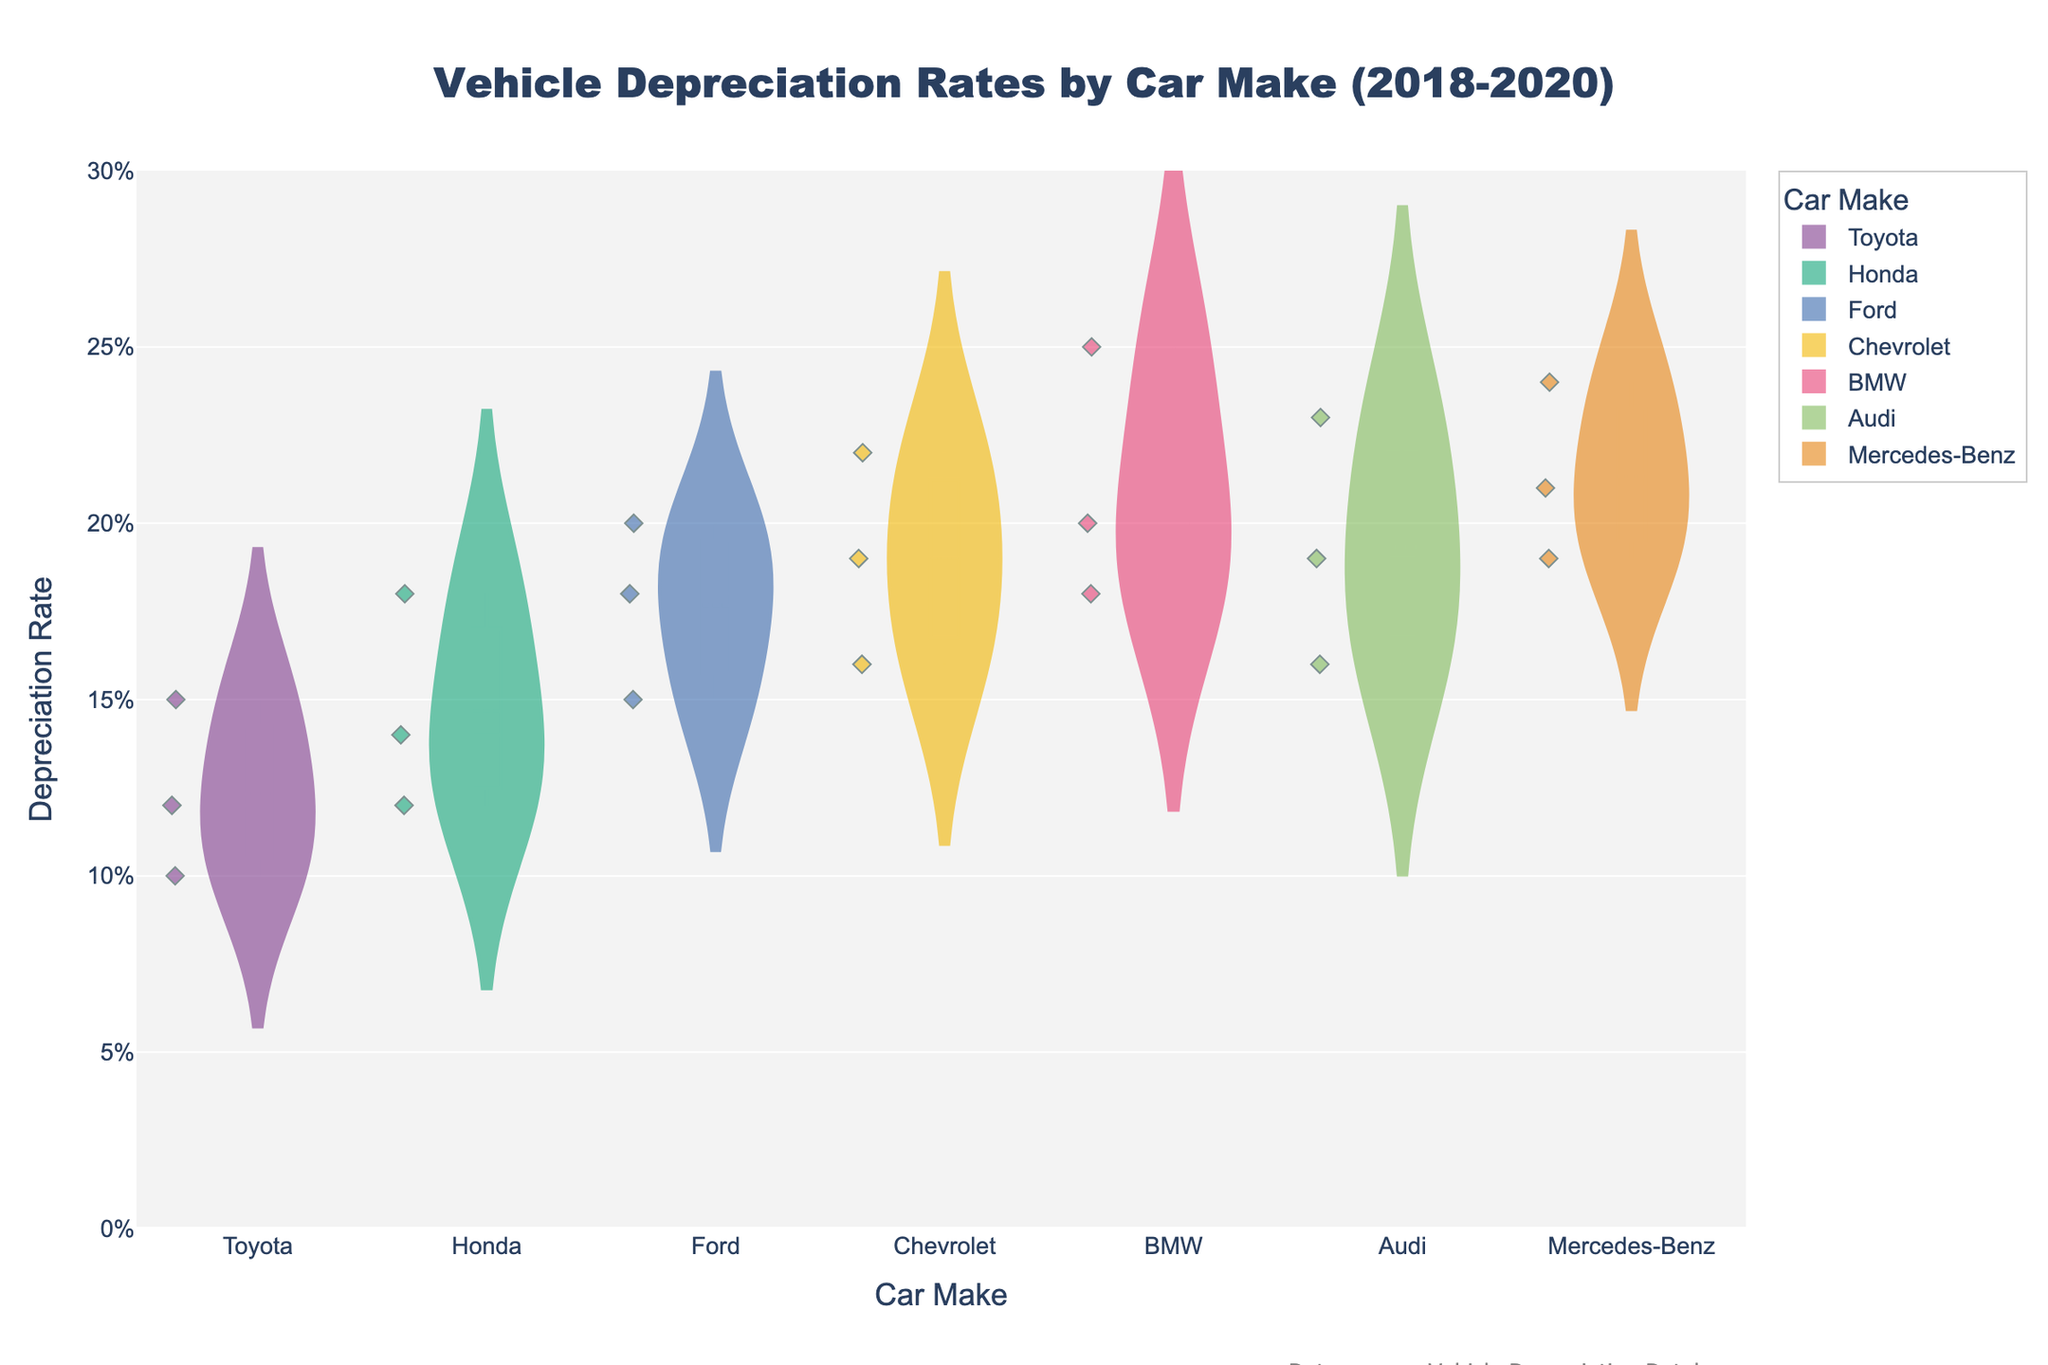What's the title of the figure? Look for the text at the top center of the figure indicating what the chart is about. It’s usually prominently displayed.
Answer: Vehicle Depreciation Rates by Car Make (2018-2020) What is the y-axis title? Check the label along the vertical axis to understand what measurement the y-axis represents.
Answer: Depreciation Rate Which car make shows the highest depreciation rate for 2018? Inspect each violin plot for 2018 and identify the peak value among all car makes.
Answer: BMW How does the depreciation rate of the Toyota Corolla in 2020 compare to that of the Honda Civic in 2020? Locate the 2020 depreciation rates for Toyota Corolla and Honda Civic, then compare the values.
Answer: Toyota Corolla has a lower depreciation rate Which car make appears to have the most distribution spread in depreciation rates over the years? Look for the violin plot with the widest spread in data points across the years.
Answer: BMW What is the range of the depreciation rates for the Ford F-150? Determine the minimum and maximum values within the violin plot for Ford F-150.
Answer: 0.15 to 0.20 Which car make has the smallest difference between its highest depreciation rate and the lowest depreciation rate? Calculate the difference between maximum and minimum values for each make, and identify the smallest difference.
Answer: Toyota Are there any outliers in the data for the Chevrolet Impala? Identify if there are any points significantly separated from the rest of the data in the Chevrolet Impala's violin plot.
Answer: No Does any car make have a mean depreciation rate that lies below 0.10 across the years shown? Check the mean line (white dot) for each make to see if any lie below 0.10.
Answer: No 